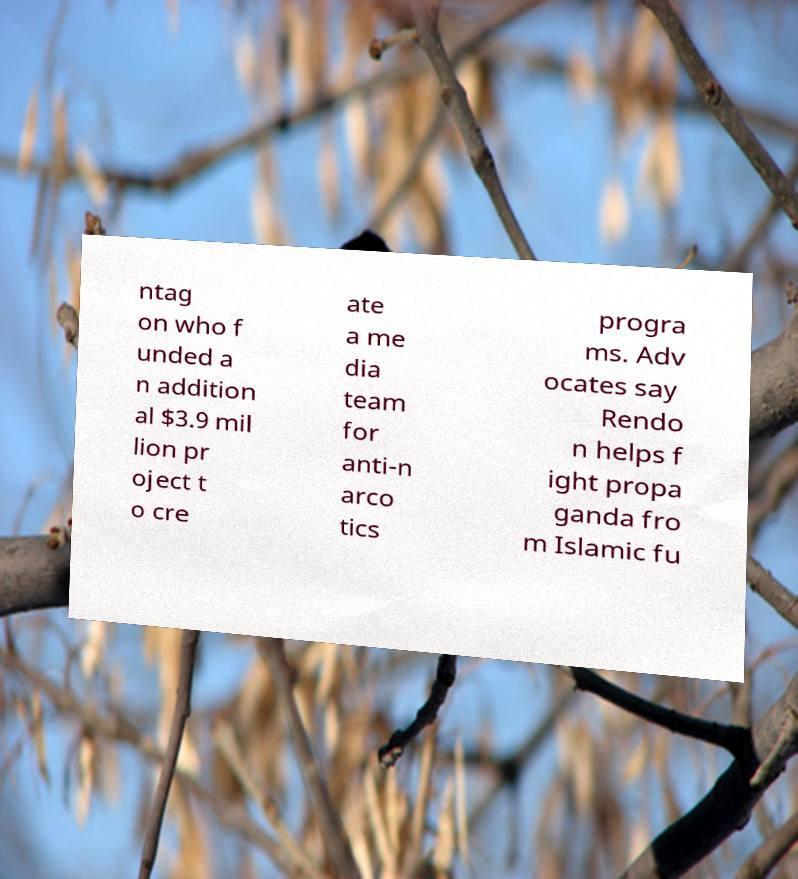Please read and relay the text visible in this image. What does it say? ntag on who f unded a n addition al $3.9 mil lion pr oject t o cre ate a me dia team for anti-n arco tics progra ms. Adv ocates say Rendo n helps f ight propa ganda fro m Islamic fu 